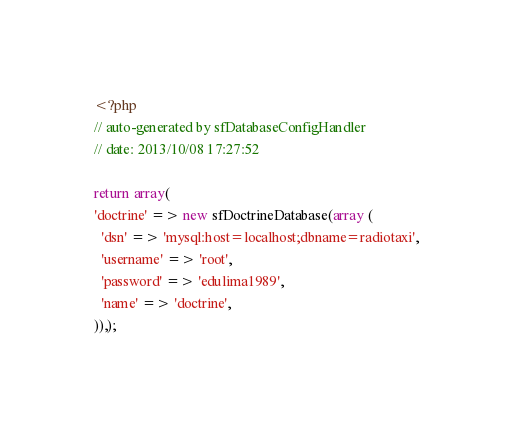<code> <loc_0><loc_0><loc_500><loc_500><_PHP_><?php
// auto-generated by sfDatabaseConfigHandler
// date: 2013/10/08 17:27:52

return array(
'doctrine' => new sfDoctrineDatabase(array (
  'dsn' => 'mysql:host=localhost;dbname=radiotaxi',
  'username' => 'root',
  'password' => 'edulima1989',
  'name' => 'doctrine',
)),);
</code> 